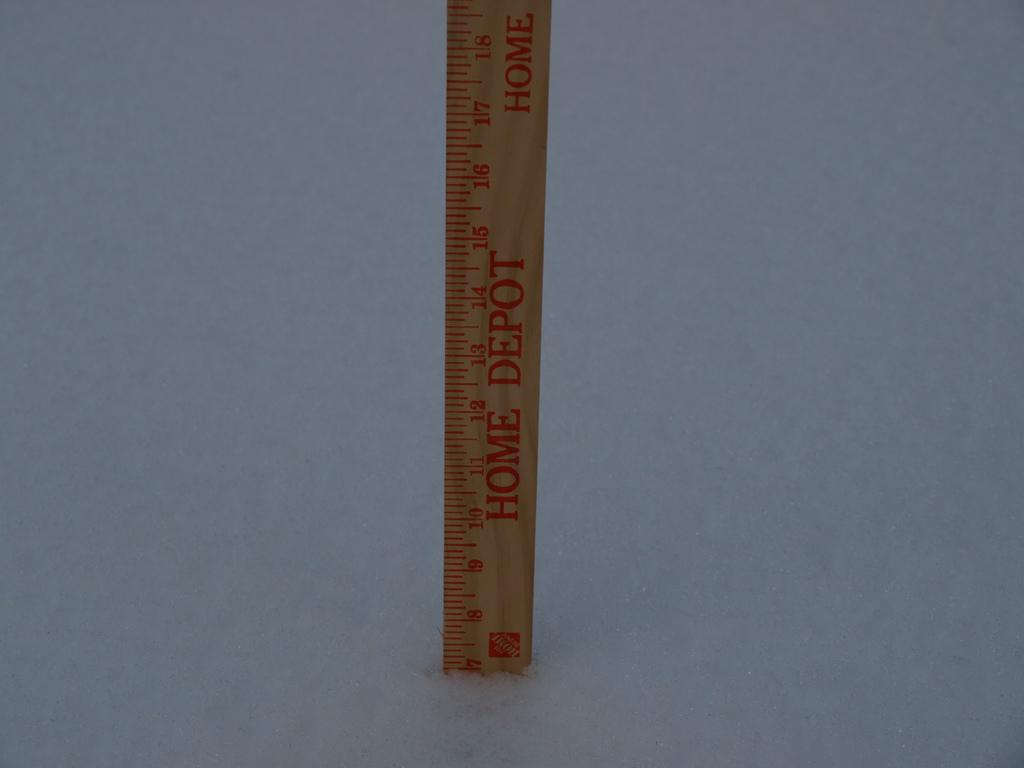What object is on the ground in the image? There is a scale on the ground in the image. What features can be seen on the scale? The scale has numbers and text on it. What type of weather is depicted in the image? There is snow on the ground in the image. What route is the scale taking through the bedroom in the image? There is no bedroom or route present in the image; it features a scale on the snowy ground. 